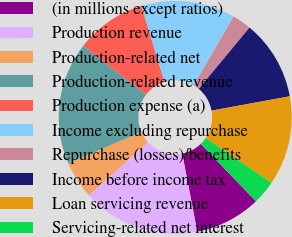<chart> <loc_0><loc_0><loc_500><loc_500><pie_chart><fcel>(in millions except ratios)<fcel>Production revenue<fcel>Production-related net<fcel>Production-related revenue<fcel>Production expense (a)<fcel>Income excluding repurchase<fcel>Repurchase (losses)/benefits<fcel>Income before income tax<fcel>Loan servicing revenue<fcel>Servicing-related net interest<nl><fcel>9.15%<fcel>16.31%<fcel>5.25%<fcel>16.97%<fcel>9.8%<fcel>13.06%<fcel>2.64%<fcel>11.11%<fcel>12.41%<fcel>3.29%<nl></chart> 